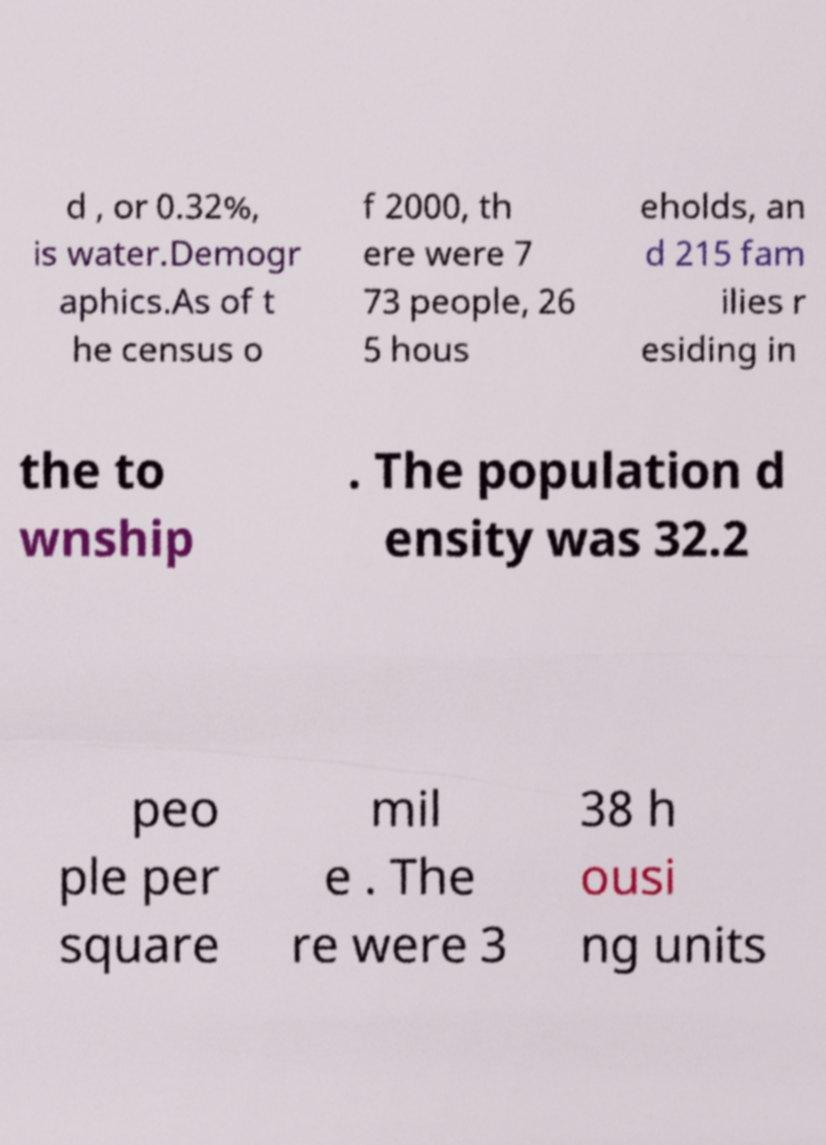Could you extract and type out the text from this image? d , or 0.32%, is water.Demogr aphics.As of t he census o f 2000, th ere were 7 73 people, 26 5 hous eholds, an d 215 fam ilies r esiding in the to wnship . The population d ensity was 32.2 peo ple per square mil e . The re were 3 38 h ousi ng units 